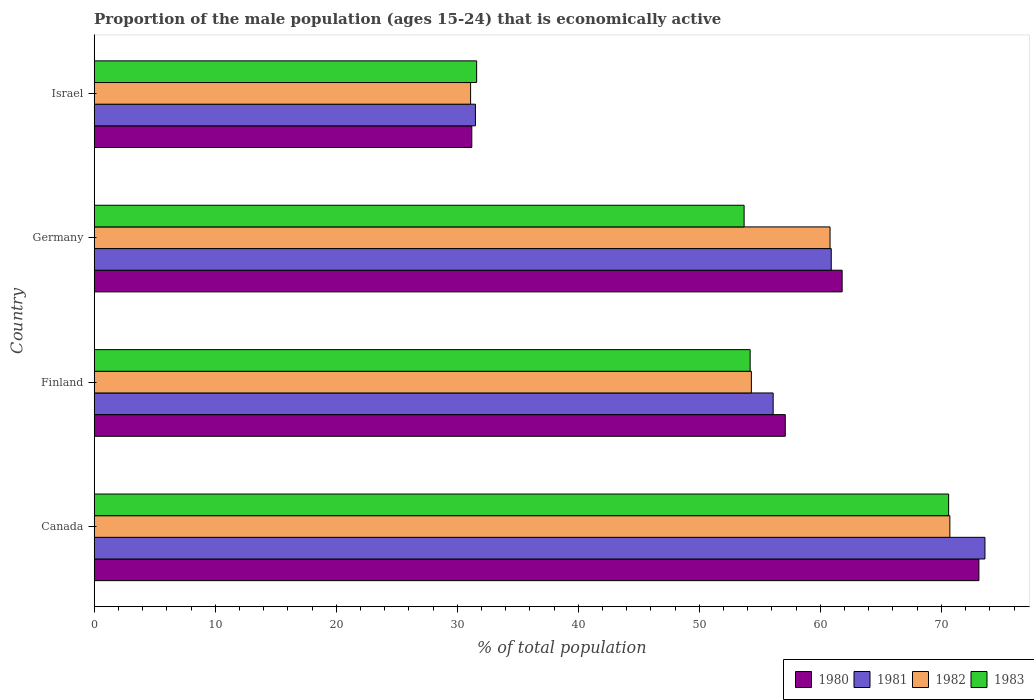Are the number of bars per tick equal to the number of legend labels?
Offer a very short reply. Yes. Are the number of bars on each tick of the Y-axis equal?
Offer a terse response. Yes. How many bars are there on the 1st tick from the bottom?
Provide a short and direct response. 4. What is the proportion of the male population that is economically active in 1980 in Germany?
Keep it short and to the point. 61.8. Across all countries, what is the maximum proportion of the male population that is economically active in 1980?
Ensure brevity in your answer.  73.1. Across all countries, what is the minimum proportion of the male population that is economically active in 1980?
Offer a very short reply. 31.2. What is the total proportion of the male population that is economically active in 1983 in the graph?
Provide a succinct answer. 210.1. What is the difference between the proportion of the male population that is economically active in 1981 in Canada and that in Israel?
Your answer should be compact. 42.1. What is the difference between the proportion of the male population that is economically active in 1982 in Israel and the proportion of the male population that is economically active in 1983 in Germany?
Keep it short and to the point. -22.6. What is the average proportion of the male population that is economically active in 1982 per country?
Provide a succinct answer. 54.22. What is the difference between the proportion of the male population that is economically active in 1980 and proportion of the male population that is economically active in 1981 in Israel?
Give a very brief answer. -0.3. What is the ratio of the proportion of the male population that is economically active in 1983 in Canada to that in Finland?
Your answer should be compact. 1.3. Is the proportion of the male population that is economically active in 1983 in Finland less than that in Germany?
Provide a short and direct response. No. Is the difference between the proportion of the male population that is economically active in 1980 in Canada and Finland greater than the difference between the proportion of the male population that is economically active in 1981 in Canada and Finland?
Offer a very short reply. No. What is the difference between the highest and the second highest proportion of the male population that is economically active in 1982?
Provide a succinct answer. 9.9. What is the difference between the highest and the lowest proportion of the male population that is economically active in 1983?
Your answer should be very brief. 39. In how many countries, is the proportion of the male population that is economically active in 1981 greater than the average proportion of the male population that is economically active in 1981 taken over all countries?
Your answer should be very brief. 3. Is the sum of the proportion of the male population that is economically active in 1983 in Germany and Israel greater than the maximum proportion of the male population that is economically active in 1980 across all countries?
Offer a very short reply. Yes. What is the difference between two consecutive major ticks on the X-axis?
Make the answer very short. 10. Are the values on the major ticks of X-axis written in scientific E-notation?
Give a very brief answer. No. Where does the legend appear in the graph?
Make the answer very short. Bottom right. What is the title of the graph?
Give a very brief answer. Proportion of the male population (ages 15-24) that is economically active. Does "2005" appear as one of the legend labels in the graph?
Keep it short and to the point. No. What is the label or title of the X-axis?
Your answer should be very brief. % of total population. What is the % of total population in 1980 in Canada?
Offer a terse response. 73.1. What is the % of total population in 1981 in Canada?
Provide a succinct answer. 73.6. What is the % of total population of 1982 in Canada?
Your answer should be very brief. 70.7. What is the % of total population in 1983 in Canada?
Keep it short and to the point. 70.6. What is the % of total population of 1980 in Finland?
Keep it short and to the point. 57.1. What is the % of total population of 1981 in Finland?
Offer a very short reply. 56.1. What is the % of total population in 1982 in Finland?
Make the answer very short. 54.3. What is the % of total population in 1983 in Finland?
Offer a very short reply. 54.2. What is the % of total population in 1980 in Germany?
Give a very brief answer. 61.8. What is the % of total population of 1981 in Germany?
Provide a succinct answer. 60.9. What is the % of total population of 1982 in Germany?
Your answer should be compact. 60.8. What is the % of total population in 1983 in Germany?
Offer a very short reply. 53.7. What is the % of total population of 1980 in Israel?
Provide a short and direct response. 31.2. What is the % of total population of 1981 in Israel?
Give a very brief answer. 31.5. What is the % of total population of 1982 in Israel?
Provide a short and direct response. 31.1. What is the % of total population in 1983 in Israel?
Keep it short and to the point. 31.6. Across all countries, what is the maximum % of total population in 1980?
Provide a succinct answer. 73.1. Across all countries, what is the maximum % of total population of 1981?
Your answer should be compact. 73.6. Across all countries, what is the maximum % of total population of 1982?
Offer a terse response. 70.7. Across all countries, what is the maximum % of total population in 1983?
Your answer should be compact. 70.6. Across all countries, what is the minimum % of total population of 1980?
Your answer should be compact. 31.2. Across all countries, what is the minimum % of total population in 1981?
Offer a terse response. 31.5. Across all countries, what is the minimum % of total population in 1982?
Your answer should be very brief. 31.1. Across all countries, what is the minimum % of total population in 1983?
Keep it short and to the point. 31.6. What is the total % of total population of 1980 in the graph?
Provide a short and direct response. 223.2. What is the total % of total population of 1981 in the graph?
Your response must be concise. 222.1. What is the total % of total population of 1982 in the graph?
Provide a succinct answer. 216.9. What is the total % of total population in 1983 in the graph?
Your answer should be very brief. 210.1. What is the difference between the % of total population in 1981 in Canada and that in Finland?
Keep it short and to the point. 17.5. What is the difference between the % of total population in 1983 in Canada and that in Finland?
Your answer should be compact. 16.4. What is the difference between the % of total population in 1980 in Canada and that in Germany?
Offer a terse response. 11.3. What is the difference between the % of total population in 1981 in Canada and that in Germany?
Your answer should be compact. 12.7. What is the difference between the % of total population of 1980 in Canada and that in Israel?
Your response must be concise. 41.9. What is the difference between the % of total population of 1981 in Canada and that in Israel?
Offer a very short reply. 42.1. What is the difference between the % of total population of 1982 in Canada and that in Israel?
Give a very brief answer. 39.6. What is the difference between the % of total population in 1980 in Finland and that in Germany?
Offer a terse response. -4.7. What is the difference between the % of total population of 1981 in Finland and that in Germany?
Keep it short and to the point. -4.8. What is the difference between the % of total population of 1982 in Finland and that in Germany?
Provide a short and direct response. -6.5. What is the difference between the % of total population in 1980 in Finland and that in Israel?
Provide a succinct answer. 25.9. What is the difference between the % of total population of 1981 in Finland and that in Israel?
Your answer should be compact. 24.6. What is the difference between the % of total population of 1982 in Finland and that in Israel?
Give a very brief answer. 23.2. What is the difference between the % of total population in 1983 in Finland and that in Israel?
Offer a terse response. 22.6. What is the difference between the % of total population in 1980 in Germany and that in Israel?
Offer a very short reply. 30.6. What is the difference between the % of total population of 1981 in Germany and that in Israel?
Your answer should be very brief. 29.4. What is the difference between the % of total population in 1982 in Germany and that in Israel?
Your response must be concise. 29.7. What is the difference between the % of total population in 1983 in Germany and that in Israel?
Provide a short and direct response. 22.1. What is the difference between the % of total population of 1980 in Canada and the % of total population of 1983 in Finland?
Offer a very short reply. 18.9. What is the difference between the % of total population in 1981 in Canada and the % of total population in 1982 in Finland?
Offer a very short reply. 19.3. What is the difference between the % of total population in 1981 in Canada and the % of total population in 1983 in Finland?
Ensure brevity in your answer.  19.4. What is the difference between the % of total population of 1982 in Canada and the % of total population of 1983 in Finland?
Provide a succinct answer. 16.5. What is the difference between the % of total population in 1980 in Canada and the % of total population in 1983 in Germany?
Give a very brief answer. 19.4. What is the difference between the % of total population of 1981 in Canada and the % of total population of 1982 in Germany?
Offer a very short reply. 12.8. What is the difference between the % of total population of 1981 in Canada and the % of total population of 1983 in Germany?
Your answer should be compact. 19.9. What is the difference between the % of total population of 1980 in Canada and the % of total population of 1981 in Israel?
Offer a very short reply. 41.6. What is the difference between the % of total population in 1980 in Canada and the % of total population in 1982 in Israel?
Provide a short and direct response. 42. What is the difference between the % of total population in 1980 in Canada and the % of total population in 1983 in Israel?
Provide a short and direct response. 41.5. What is the difference between the % of total population in 1981 in Canada and the % of total population in 1982 in Israel?
Provide a short and direct response. 42.5. What is the difference between the % of total population in 1981 in Canada and the % of total population in 1983 in Israel?
Give a very brief answer. 42. What is the difference between the % of total population of 1982 in Canada and the % of total population of 1983 in Israel?
Keep it short and to the point. 39.1. What is the difference between the % of total population of 1980 in Finland and the % of total population of 1981 in Germany?
Offer a terse response. -3.8. What is the difference between the % of total population in 1980 in Finland and the % of total population in 1982 in Germany?
Provide a short and direct response. -3.7. What is the difference between the % of total population in 1981 in Finland and the % of total population in 1983 in Germany?
Your response must be concise. 2.4. What is the difference between the % of total population in 1982 in Finland and the % of total population in 1983 in Germany?
Offer a very short reply. 0.6. What is the difference between the % of total population of 1980 in Finland and the % of total population of 1981 in Israel?
Provide a short and direct response. 25.6. What is the difference between the % of total population of 1980 in Finland and the % of total population of 1983 in Israel?
Keep it short and to the point. 25.5. What is the difference between the % of total population in 1981 in Finland and the % of total population in 1983 in Israel?
Make the answer very short. 24.5. What is the difference between the % of total population in 1982 in Finland and the % of total population in 1983 in Israel?
Provide a succinct answer. 22.7. What is the difference between the % of total population in 1980 in Germany and the % of total population in 1981 in Israel?
Your answer should be very brief. 30.3. What is the difference between the % of total population in 1980 in Germany and the % of total population in 1982 in Israel?
Offer a terse response. 30.7. What is the difference between the % of total population in 1980 in Germany and the % of total population in 1983 in Israel?
Ensure brevity in your answer.  30.2. What is the difference between the % of total population of 1981 in Germany and the % of total population of 1982 in Israel?
Offer a terse response. 29.8. What is the difference between the % of total population of 1981 in Germany and the % of total population of 1983 in Israel?
Your answer should be very brief. 29.3. What is the difference between the % of total population in 1982 in Germany and the % of total population in 1983 in Israel?
Give a very brief answer. 29.2. What is the average % of total population in 1980 per country?
Offer a very short reply. 55.8. What is the average % of total population in 1981 per country?
Offer a very short reply. 55.52. What is the average % of total population of 1982 per country?
Your response must be concise. 54.23. What is the average % of total population in 1983 per country?
Ensure brevity in your answer.  52.52. What is the difference between the % of total population of 1981 and % of total population of 1983 in Canada?
Give a very brief answer. 3. What is the difference between the % of total population of 1982 and % of total population of 1983 in Canada?
Provide a short and direct response. 0.1. What is the difference between the % of total population of 1981 and % of total population of 1982 in Finland?
Provide a succinct answer. 1.8. What is the difference between the % of total population of 1982 and % of total population of 1983 in Finland?
Offer a very short reply. 0.1. What is the difference between the % of total population of 1980 and % of total population of 1981 in Germany?
Offer a very short reply. 0.9. What is the difference between the % of total population of 1980 and % of total population of 1981 in Israel?
Make the answer very short. -0.3. What is the difference between the % of total population in 1980 and % of total population in 1982 in Israel?
Your answer should be compact. 0.1. What is the difference between the % of total population of 1982 and % of total population of 1983 in Israel?
Ensure brevity in your answer.  -0.5. What is the ratio of the % of total population in 1980 in Canada to that in Finland?
Offer a terse response. 1.28. What is the ratio of the % of total population in 1981 in Canada to that in Finland?
Offer a terse response. 1.31. What is the ratio of the % of total population of 1982 in Canada to that in Finland?
Offer a very short reply. 1.3. What is the ratio of the % of total population in 1983 in Canada to that in Finland?
Your answer should be very brief. 1.3. What is the ratio of the % of total population in 1980 in Canada to that in Germany?
Your answer should be compact. 1.18. What is the ratio of the % of total population of 1981 in Canada to that in Germany?
Make the answer very short. 1.21. What is the ratio of the % of total population of 1982 in Canada to that in Germany?
Provide a succinct answer. 1.16. What is the ratio of the % of total population of 1983 in Canada to that in Germany?
Your answer should be very brief. 1.31. What is the ratio of the % of total population in 1980 in Canada to that in Israel?
Offer a terse response. 2.34. What is the ratio of the % of total population in 1981 in Canada to that in Israel?
Your answer should be very brief. 2.34. What is the ratio of the % of total population in 1982 in Canada to that in Israel?
Provide a short and direct response. 2.27. What is the ratio of the % of total population in 1983 in Canada to that in Israel?
Your answer should be very brief. 2.23. What is the ratio of the % of total population in 1980 in Finland to that in Germany?
Provide a short and direct response. 0.92. What is the ratio of the % of total population of 1981 in Finland to that in Germany?
Your response must be concise. 0.92. What is the ratio of the % of total population in 1982 in Finland to that in Germany?
Make the answer very short. 0.89. What is the ratio of the % of total population of 1983 in Finland to that in Germany?
Provide a short and direct response. 1.01. What is the ratio of the % of total population of 1980 in Finland to that in Israel?
Your response must be concise. 1.83. What is the ratio of the % of total population of 1981 in Finland to that in Israel?
Give a very brief answer. 1.78. What is the ratio of the % of total population in 1982 in Finland to that in Israel?
Give a very brief answer. 1.75. What is the ratio of the % of total population in 1983 in Finland to that in Israel?
Your answer should be compact. 1.72. What is the ratio of the % of total population of 1980 in Germany to that in Israel?
Give a very brief answer. 1.98. What is the ratio of the % of total population in 1981 in Germany to that in Israel?
Offer a terse response. 1.93. What is the ratio of the % of total population of 1982 in Germany to that in Israel?
Your answer should be compact. 1.96. What is the ratio of the % of total population of 1983 in Germany to that in Israel?
Provide a succinct answer. 1.7. What is the difference between the highest and the second highest % of total population of 1981?
Provide a succinct answer. 12.7. What is the difference between the highest and the lowest % of total population of 1980?
Make the answer very short. 41.9. What is the difference between the highest and the lowest % of total population in 1981?
Keep it short and to the point. 42.1. What is the difference between the highest and the lowest % of total population of 1982?
Your answer should be very brief. 39.6. What is the difference between the highest and the lowest % of total population of 1983?
Your response must be concise. 39. 